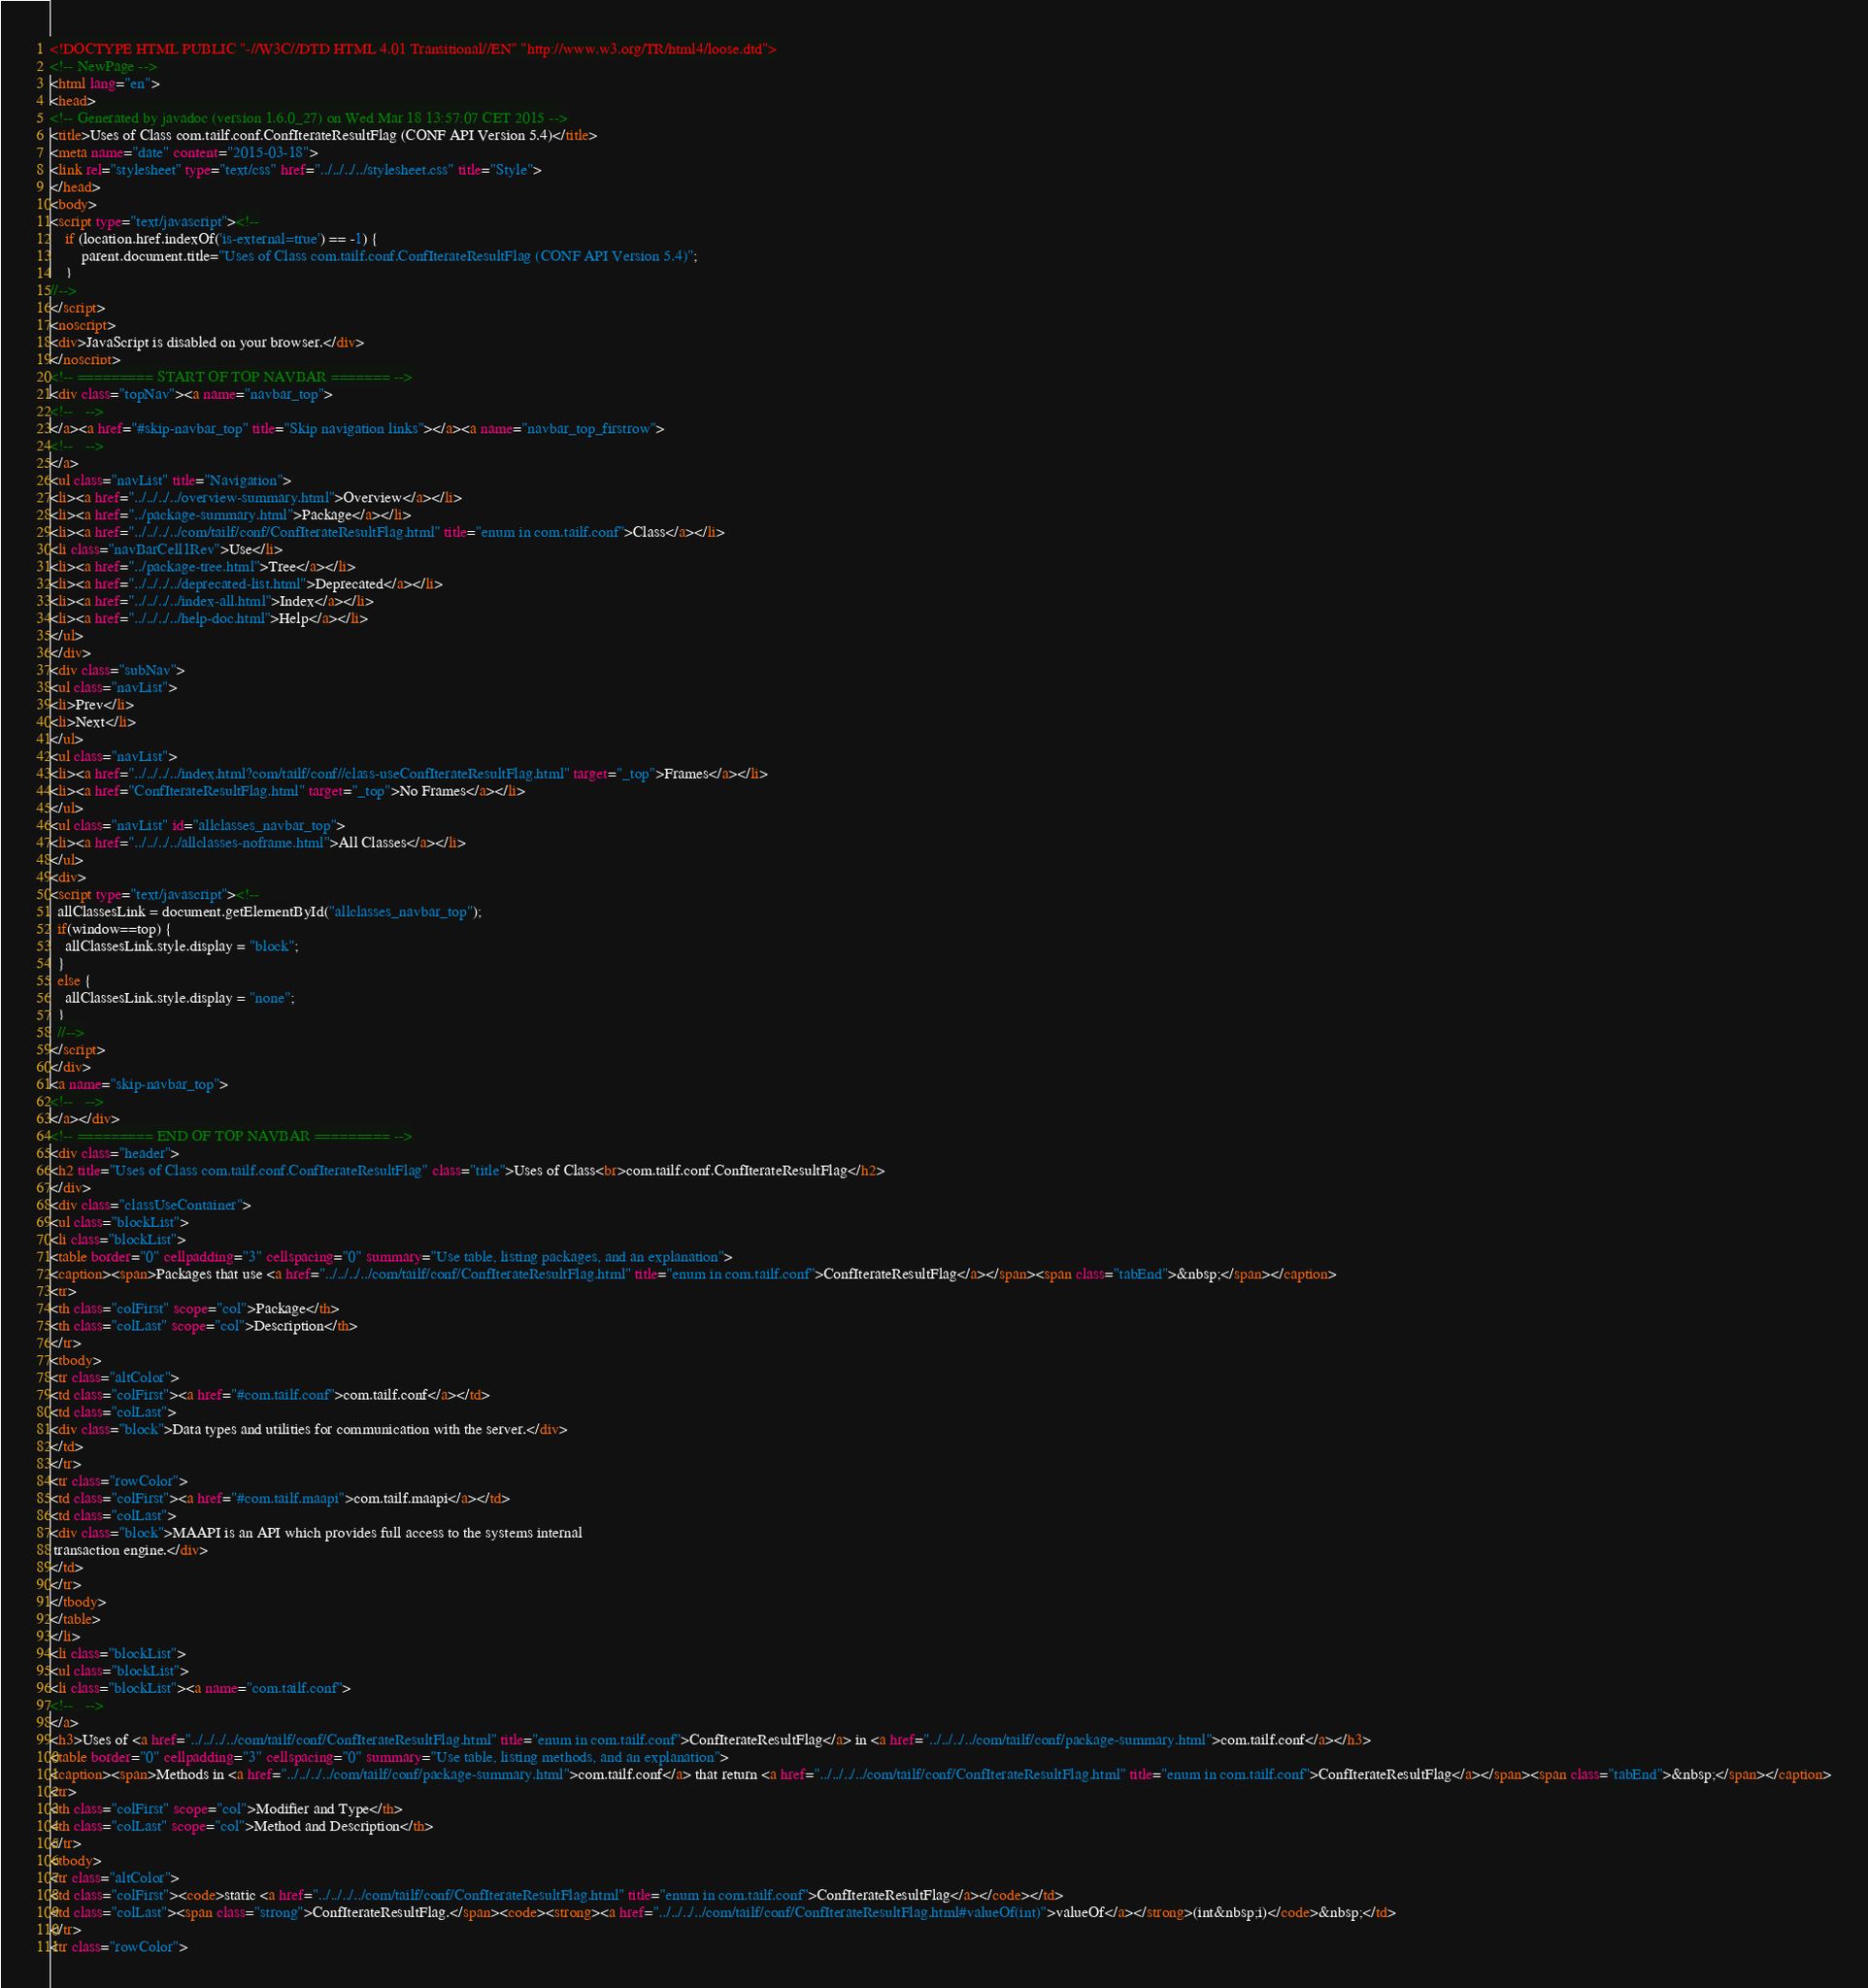Convert code to text. <code><loc_0><loc_0><loc_500><loc_500><_HTML_><!DOCTYPE HTML PUBLIC "-//W3C//DTD HTML 4.01 Transitional//EN" "http://www.w3.org/TR/html4/loose.dtd">
<!-- NewPage -->
<html lang="en">
<head>
<!-- Generated by javadoc (version 1.6.0_27) on Wed Mar 18 13:57:07 CET 2015 -->
<title>Uses of Class com.tailf.conf.ConfIterateResultFlag (CONF API Version 5.4)</title>
<meta name="date" content="2015-03-18">
<link rel="stylesheet" type="text/css" href="../../../../stylesheet.css" title="Style">
</head>
<body>
<script type="text/javascript"><!--
    if (location.href.indexOf('is-external=true') == -1) {
        parent.document.title="Uses of Class com.tailf.conf.ConfIterateResultFlag (CONF API Version 5.4)";
    }
//-->
</script>
<noscript>
<div>JavaScript is disabled on your browser.</div>
</noscript>
<!-- ========= START OF TOP NAVBAR ======= -->
<div class="topNav"><a name="navbar_top">
<!--   -->
</a><a href="#skip-navbar_top" title="Skip navigation links"></a><a name="navbar_top_firstrow">
<!--   -->
</a>
<ul class="navList" title="Navigation">
<li><a href="../../../../overview-summary.html">Overview</a></li>
<li><a href="../package-summary.html">Package</a></li>
<li><a href="../../../../com/tailf/conf/ConfIterateResultFlag.html" title="enum in com.tailf.conf">Class</a></li>
<li class="navBarCell1Rev">Use</li>
<li><a href="../package-tree.html">Tree</a></li>
<li><a href="../../../../deprecated-list.html">Deprecated</a></li>
<li><a href="../../../../index-all.html">Index</a></li>
<li><a href="../../../../help-doc.html">Help</a></li>
</ul>
</div>
<div class="subNav">
<ul class="navList">
<li>Prev</li>
<li>Next</li>
</ul>
<ul class="navList">
<li><a href="../../../../index.html?com/tailf/conf//class-useConfIterateResultFlag.html" target="_top">Frames</a></li>
<li><a href="ConfIterateResultFlag.html" target="_top">No Frames</a></li>
</ul>
<ul class="navList" id="allclasses_navbar_top">
<li><a href="../../../../allclasses-noframe.html">All Classes</a></li>
</ul>
<div>
<script type="text/javascript"><!--
  allClassesLink = document.getElementById("allclasses_navbar_top");
  if(window==top) {
    allClassesLink.style.display = "block";
  }
  else {
    allClassesLink.style.display = "none";
  }
  //-->
</script>
</div>
<a name="skip-navbar_top">
<!--   -->
</a></div>
<!-- ========= END OF TOP NAVBAR ========= -->
<div class="header">
<h2 title="Uses of Class com.tailf.conf.ConfIterateResultFlag" class="title">Uses of Class<br>com.tailf.conf.ConfIterateResultFlag</h2>
</div>
<div class="classUseContainer">
<ul class="blockList">
<li class="blockList">
<table border="0" cellpadding="3" cellspacing="0" summary="Use table, listing packages, and an explanation">
<caption><span>Packages that use <a href="../../../../com/tailf/conf/ConfIterateResultFlag.html" title="enum in com.tailf.conf">ConfIterateResultFlag</a></span><span class="tabEnd">&nbsp;</span></caption>
<tr>
<th class="colFirst" scope="col">Package</th>
<th class="colLast" scope="col">Description</th>
</tr>
<tbody>
<tr class="altColor">
<td class="colFirst"><a href="#com.tailf.conf">com.tailf.conf</a></td>
<td class="colLast">
<div class="block">Data types and utilities for communication with the server.</div>
</td>
</tr>
<tr class="rowColor">
<td class="colFirst"><a href="#com.tailf.maapi">com.tailf.maapi</a></td>
<td class="colLast">
<div class="block">MAAPI is an API which provides full access to the systems internal
 transaction engine.</div>
</td>
</tr>
</tbody>
</table>
</li>
<li class="blockList">
<ul class="blockList">
<li class="blockList"><a name="com.tailf.conf">
<!--   -->
</a>
<h3>Uses of <a href="../../../../com/tailf/conf/ConfIterateResultFlag.html" title="enum in com.tailf.conf">ConfIterateResultFlag</a> in <a href="../../../../com/tailf/conf/package-summary.html">com.tailf.conf</a></h3>
<table border="0" cellpadding="3" cellspacing="0" summary="Use table, listing methods, and an explanation">
<caption><span>Methods in <a href="../../../../com/tailf/conf/package-summary.html">com.tailf.conf</a> that return <a href="../../../../com/tailf/conf/ConfIterateResultFlag.html" title="enum in com.tailf.conf">ConfIterateResultFlag</a></span><span class="tabEnd">&nbsp;</span></caption>
<tr>
<th class="colFirst" scope="col">Modifier and Type</th>
<th class="colLast" scope="col">Method and Description</th>
</tr>
<tbody>
<tr class="altColor">
<td class="colFirst"><code>static <a href="../../../../com/tailf/conf/ConfIterateResultFlag.html" title="enum in com.tailf.conf">ConfIterateResultFlag</a></code></td>
<td class="colLast"><span class="strong">ConfIterateResultFlag.</span><code><strong><a href="../../../../com/tailf/conf/ConfIterateResultFlag.html#valueOf(int)">valueOf</a></strong>(int&nbsp;i)</code>&nbsp;</td>
</tr>
<tr class="rowColor"></code> 